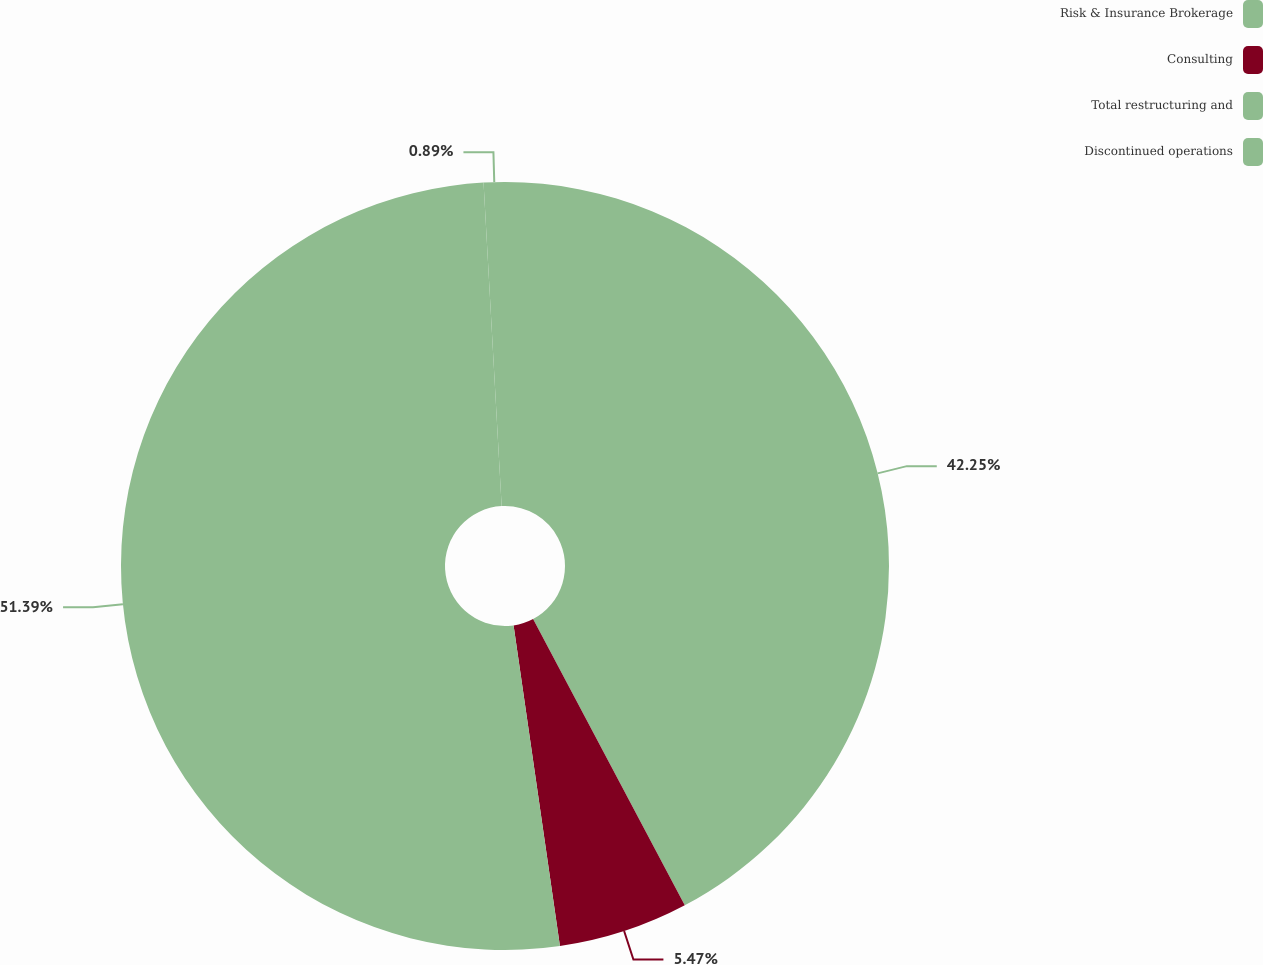Convert chart. <chart><loc_0><loc_0><loc_500><loc_500><pie_chart><fcel>Risk & Insurance Brokerage<fcel>Consulting<fcel>Total restructuring and<fcel>Discontinued operations<nl><fcel>42.25%<fcel>5.47%<fcel>51.4%<fcel>0.89%<nl></chart> 